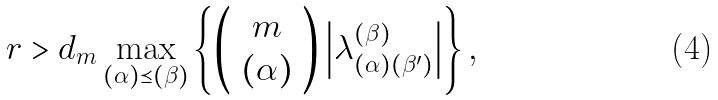Convert formula to latex. <formula><loc_0><loc_0><loc_500><loc_500>r > d _ { m } \max _ { ( \alpha ) \preceq ( \beta ) } \left \{ \left ( \begin{array} { c } m \\ ( \alpha ) \end{array} \right ) \left | \lambda _ { ( \alpha ) ( \beta ^ { \prime } ) } ^ { ( \beta ) } \right | \right \} ,</formula> 